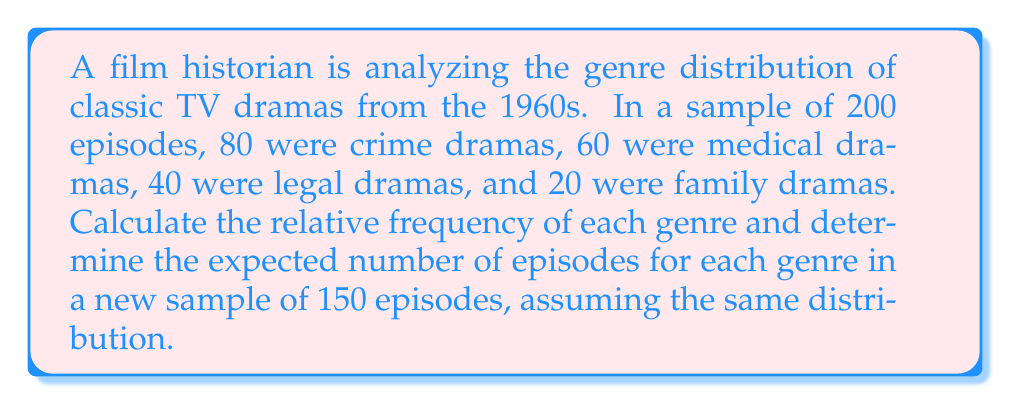Help me with this question. 1. Calculate the relative frequency for each genre:
   - Total episodes: 200
   - Relative frequency = Number of episodes in genre / Total episodes
   
   Crime dramas: $f_c = \frac{80}{200} = 0.4$ or 40%
   Medical dramas: $f_m = \frac{60}{200} = 0.3$ or 30%
   Legal dramas: $f_l = \frac{40}{200} = 0.2$ or 20%
   Family dramas: $f_f = \frac{20}{200} = 0.1$ or 10%

2. To find the expected number of episodes for each genre in a new sample of 150 episodes:
   - Multiply the relative frequency by the new sample size

   Crime dramas: $E_c = 0.4 \times 150 = 60$ episodes
   Medical dramas: $E_m = 0.3 \times 150 = 45$ episodes
   Legal dramas: $E_l = 0.2 \times 150 = 30$ episodes
   Family dramas: $E_f = 0.1 \times 150 = 15$ episodes

3. Verify that the sum of expected episodes equals the new sample size:
   $60 + 45 + 30 + 15 = 150$
Answer: Crime: 60, Medical: 45, Legal: 30, Family: 15 